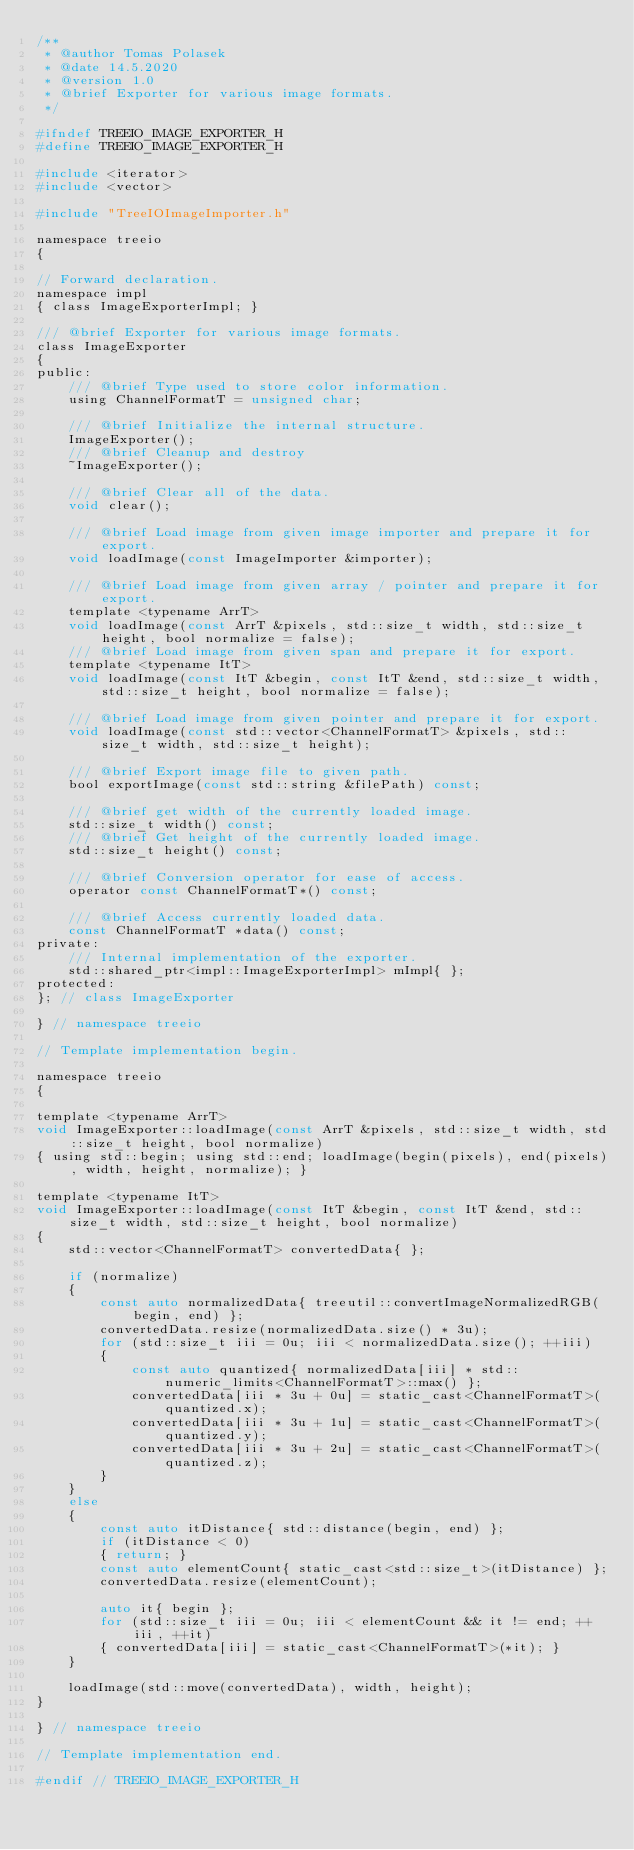<code> <loc_0><loc_0><loc_500><loc_500><_C_>/**
 * @author Tomas Polasek
 * @date 14.5.2020
 * @version 1.0
 * @brief Exporter for various image formats.
 */

#ifndef TREEIO_IMAGE_EXPORTER_H
#define TREEIO_IMAGE_EXPORTER_H

#include <iterator>
#include <vector>

#include "TreeIOImageImporter.h"

namespace treeio
{

// Forward declaration.
namespace impl
{ class ImageExporterImpl; }

/// @brief Exporter for various image formats.
class ImageExporter
{
public:
    /// @brief Type used to store color information.
    using ChannelFormatT = unsigned char;

    /// @brief Initialize the internal structure.
    ImageExporter();
    /// @brief Cleanup and destroy
    ~ImageExporter();

    /// @brief Clear all of the data.
    void clear();

    /// @brief Load image from given image importer and prepare it for export.
    void loadImage(const ImageImporter &importer);

    /// @brief Load image from given array / pointer and prepare it for export.
    template <typename ArrT>
    void loadImage(const ArrT &pixels, std::size_t width, std::size_t height, bool normalize = false);
    /// @brief Load image from given span and prepare it for export.
    template <typename ItT>
    void loadImage(const ItT &begin, const ItT &end, std::size_t width, std::size_t height, bool normalize = false);

    /// @brief Load image from given pointer and prepare it for export.
    void loadImage(const std::vector<ChannelFormatT> &pixels, std::size_t width, std::size_t height);

    /// @brief Export image file to given path.
    bool exportImage(const std::string &filePath) const;

    /// @brief get width of the currently loaded image.
    std::size_t width() const;
    /// @brief Get height of the currently loaded image.
    std::size_t height() const;

    /// @brief Conversion operator for ease of access.
    operator const ChannelFormatT*() const;

    /// @brief Access currently loaded data.
    const ChannelFormatT *data() const;
private:
    /// Internal implementation of the exporter.
    std::shared_ptr<impl::ImageExporterImpl> mImpl{ };
protected:
}; // class ImageExporter

} // namespace treeio

// Template implementation begin.

namespace treeio
{

template <typename ArrT>
void ImageExporter::loadImage(const ArrT &pixels, std::size_t width, std::size_t height, bool normalize)
{ using std::begin; using std::end; loadImage(begin(pixels), end(pixels), width, height, normalize); }

template <typename ItT>
void ImageExporter::loadImage(const ItT &begin, const ItT &end, std::size_t width, std::size_t height, bool normalize)
{
    std::vector<ChannelFormatT> convertedData{ };

    if (normalize)
    {
        const auto normalizedData{ treeutil::convertImageNormalizedRGB(begin, end) };
        convertedData.resize(normalizedData.size() * 3u);
        for (std::size_t iii = 0u; iii < normalizedData.size(); ++iii)
        {
            const auto quantized{ normalizedData[iii] * std::numeric_limits<ChannelFormatT>::max() };
            convertedData[iii * 3u + 0u] = static_cast<ChannelFormatT>(quantized.x);
            convertedData[iii * 3u + 1u] = static_cast<ChannelFormatT>(quantized.y);
            convertedData[iii * 3u + 2u] = static_cast<ChannelFormatT>(quantized.z);
        }
    }
    else
    {
        const auto itDistance{ std::distance(begin, end) };
        if (itDistance < 0)
        { return; }
        const auto elementCount{ static_cast<std::size_t>(itDistance) };
        convertedData.resize(elementCount);

        auto it{ begin };
        for (std::size_t iii = 0u; iii < elementCount && it != end; ++iii, ++it)
        { convertedData[iii] = static_cast<ChannelFormatT>(*it); }
    }

    loadImage(std::move(convertedData), width, height);
}

} // namespace treeio

// Template implementation end.

#endif // TREEIO_IMAGE_EXPORTER_H
</code> 